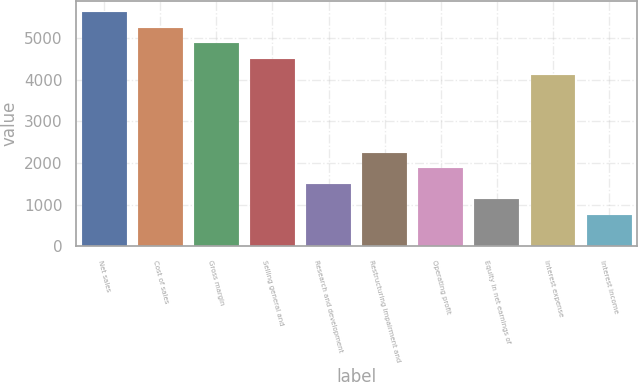Convert chart. <chart><loc_0><loc_0><loc_500><loc_500><bar_chart><fcel>Net sales<fcel>Cost of sales<fcel>Gross margin<fcel>Selling general and<fcel>Research and development<fcel>Restructuring impairment and<fcel>Operating profit<fcel>Equity in net earnings of<fcel>Interest expense<fcel>Interest income<nl><fcel>5613.5<fcel>5239.6<fcel>4865.7<fcel>4491.8<fcel>1500.6<fcel>2248.4<fcel>1874.5<fcel>1126.7<fcel>4117.9<fcel>752.8<nl></chart> 